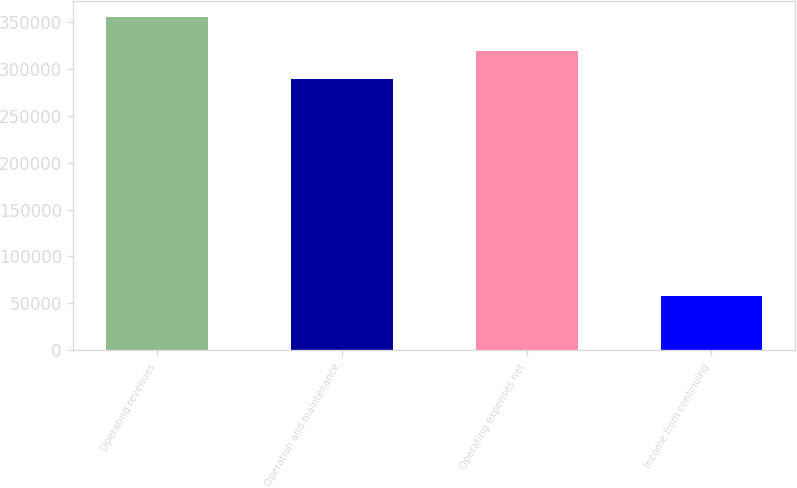Convert chart to OTSL. <chart><loc_0><loc_0><loc_500><loc_500><bar_chart><fcel>Operating revenues<fcel>Operation and maintenance<fcel>Operating expenses net<fcel>Income from continuing<nl><fcel>354679<fcel>289395<fcel>319109<fcel>57539<nl></chart> 